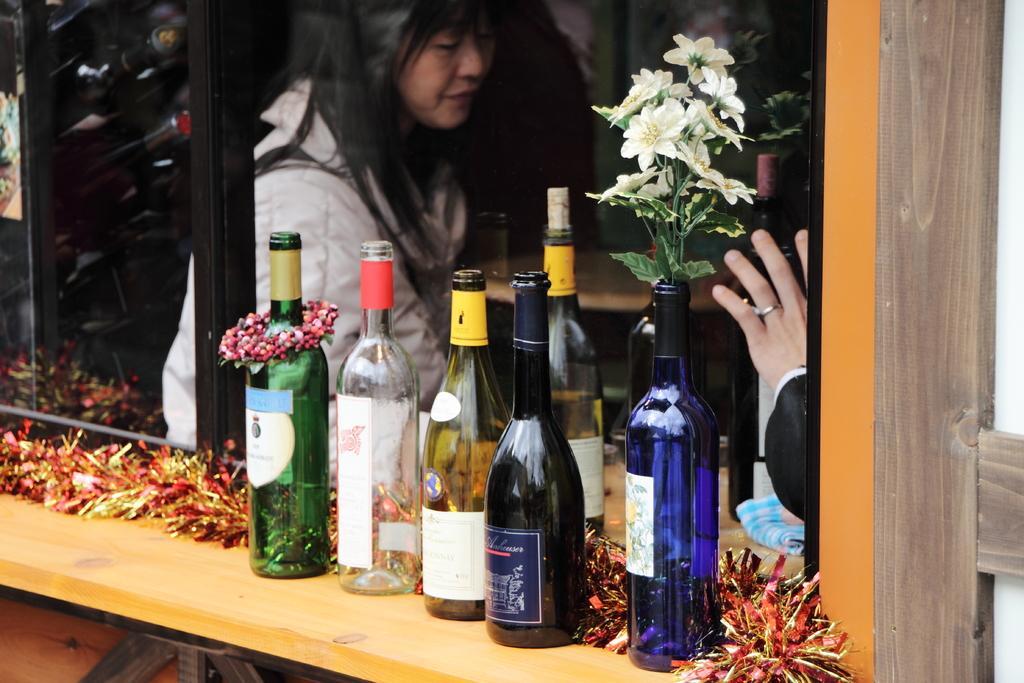In one or two sentences, can you explain what this image depicts? In this picture we can see few bottles on a table. Here we can see a flower plant inside the bottle. and also we can see a woman through glass. 